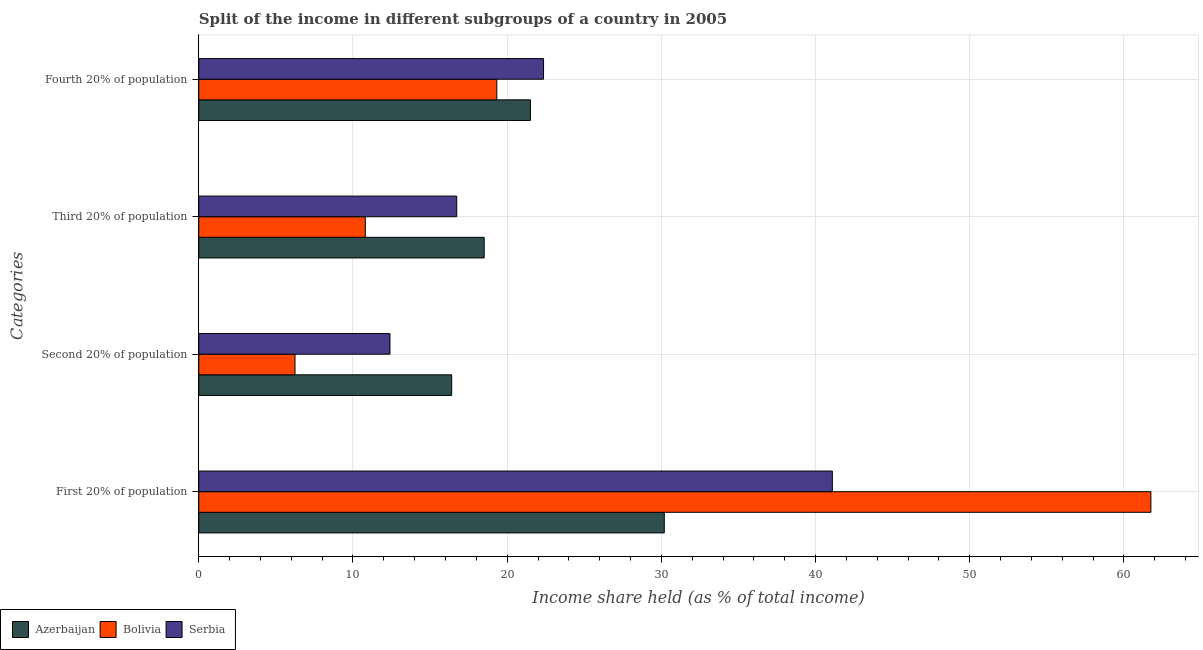How many groups of bars are there?
Provide a succinct answer. 4. Are the number of bars per tick equal to the number of legend labels?
Make the answer very short. Yes. What is the label of the 2nd group of bars from the top?
Make the answer very short. Third 20% of population. What is the share of the income held by fourth 20% of the population in Serbia?
Provide a succinct answer. 22.36. Across all countries, what is the maximum share of the income held by first 20% of the population?
Keep it short and to the point. 61.75. Across all countries, what is the minimum share of the income held by fourth 20% of the population?
Provide a short and direct response. 19.33. In which country was the share of the income held by fourth 20% of the population maximum?
Provide a succinct answer. Serbia. What is the total share of the income held by third 20% of the population in the graph?
Offer a very short reply. 46.04. What is the difference between the share of the income held by second 20% of the population in Serbia and that in Bolivia?
Your answer should be very brief. 6.16. What is the difference between the share of the income held by first 20% of the population in Bolivia and the share of the income held by fourth 20% of the population in Serbia?
Your answer should be very brief. 39.39. What is the average share of the income held by second 20% of the population per country?
Give a very brief answer. 11.68. What is the difference between the share of the income held by fourth 20% of the population and share of the income held by third 20% of the population in Bolivia?
Your response must be concise. 8.53. What is the ratio of the share of the income held by second 20% of the population in Azerbaijan to that in Serbia?
Make the answer very short. 1.32. What is the difference between the highest and the second highest share of the income held by fourth 20% of the population?
Your answer should be very brief. 0.85. What is the difference between the highest and the lowest share of the income held by fourth 20% of the population?
Offer a very short reply. 3.03. Is the sum of the share of the income held by first 20% of the population in Azerbaijan and Bolivia greater than the maximum share of the income held by second 20% of the population across all countries?
Make the answer very short. Yes. What does the 1st bar from the top in Third 20% of population represents?
Give a very brief answer. Serbia. What does the 1st bar from the bottom in Fourth 20% of population represents?
Make the answer very short. Azerbaijan. Is it the case that in every country, the sum of the share of the income held by first 20% of the population and share of the income held by second 20% of the population is greater than the share of the income held by third 20% of the population?
Provide a short and direct response. Yes. How many countries are there in the graph?
Your response must be concise. 3. What is the difference between two consecutive major ticks on the X-axis?
Your answer should be very brief. 10. Are the values on the major ticks of X-axis written in scientific E-notation?
Ensure brevity in your answer.  No. How many legend labels are there?
Offer a very short reply. 3. How are the legend labels stacked?
Your response must be concise. Horizontal. What is the title of the graph?
Provide a short and direct response. Split of the income in different subgroups of a country in 2005. What is the label or title of the X-axis?
Provide a short and direct response. Income share held (as % of total income). What is the label or title of the Y-axis?
Provide a short and direct response. Categories. What is the Income share held (as % of total income) of Azerbaijan in First 20% of population?
Make the answer very short. 30.19. What is the Income share held (as % of total income) in Bolivia in First 20% of population?
Keep it short and to the point. 61.75. What is the Income share held (as % of total income) of Serbia in First 20% of population?
Your answer should be very brief. 41.09. What is the Income share held (as % of total income) of Azerbaijan in Second 20% of population?
Offer a very short reply. 16.4. What is the Income share held (as % of total income) of Bolivia in Second 20% of population?
Ensure brevity in your answer.  6.24. What is the Income share held (as % of total income) of Azerbaijan in Third 20% of population?
Offer a very short reply. 18.51. What is the Income share held (as % of total income) in Bolivia in Third 20% of population?
Your answer should be compact. 10.8. What is the Income share held (as % of total income) of Serbia in Third 20% of population?
Your response must be concise. 16.73. What is the Income share held (as % of total income) in Azerbaijan in Fourth 20% of population?
Offer a very short reply. 21.51. What is the Income share held (as % of total income) in Bolivia in Fourth 20% of population?
Keep it short and to the point. 19.33. What is the Income share held (as % of total income) of Serbia in Fourth 20% of population?
Give a very brief answer. 22.36. Across all Categories, what is the maximum Income share held (as % of total income) of Azerbaijan?
Provide a succinct answer. 30.19. Across all Categories, what is the maximum Income share held (as % of total income) in Bolivia?
Ensure brevity in your answer.  61.75. Across all Categories, what is the maximum Income share held (as % of total income) in Serbia?
Keep it short and to the point. 41.09. Across all Categories, what is the minimum Income share held (as % of total income) of Azerbaijan?
Your response must be concise. 16.4. Across all Categories, what is the minimum Income share held (as % of total income) in Bolivia?
Offer a very short reply. 6.24. Across all Categories, what is the minimum Income share held (as % of total income) of Serbia?
Your answer should be compact. 12.4. What is the total Income share held (as % of total income) in Azerbaijan in the graph?
Ensure brevity in your answer.  86.61. What is the total Income share held (as % of total income) in Bolivia in the graph?
Ensure brevity in your answer.  98.12. What is the total Income share held (as % of total income) of Serbia in the graph?
Make the answer very short. 92.58. What is the difference between the Income share held (as % of total income) of Azerbaijan in First 20% of population and that in Second 20% of population?
Provide a succinct answer. 13.79. What is the difference between the Income share held (as % of total income) in Bolivia in First 20% of population and that in Second 20% of population?
Provide a succinct answer. 55.51. What is the difference between the Income share held (as % of total income) of Serbia in First 20% of population and that in Second 20% of population?
Offer a terse response. 28.69. What is the difference between the Income share held (as % of total income) of Azerbaijan in First 20% of population and that in Third 20% of population?
Provide a succinct answer. 11.68. What is the difference between the Income share held (as % of total income) of Bolivia in First 20% of population and that in Third 20% of population?
Provide a succinct answer. 50.95. What is the difference between the Income share held (as % of total income) of Serbia in First 20% of population and that in Third 20% of population?
Offer a very short reply. 24.36. What is the difference between the Income share held (as % of total income) in Azerbaijan in First 20% of population and that in Fourth 20% of population?
Your answer should be compact. 8.68. What is the difference between the Income share held (as % of total income) of Bolivia in First 20% of population and that in Fourth 20% of population?
Ensure brevity in your answer.  42.42. What is the difference between the Income share held (as % of total income) in Serbia in First 20% of population and that in Fourth 20% of population?
Your answer should be compact. 18.73. What is the difference between the Income share held (as % of total income) of Azerbaijan in Second 20% of population and that in Third 20% of population?
Offer a terse response. -2.11. What is the difference between the Income share held (as % of total income) of Bolivia in Second 20% of population and that in Third 20% of population?
Offer a very short reply. -4.56. What is the difference between the Income share held (as % of total income) of Serbia in Second 20% of population and that in Third 20% of population?
Provide a short and direct response. -4.33. What is the difference between the Income share held (as % of total income) of Azerbaijan in Second 20% of population and that in Fourth 20% of population?
Your answer should be compact. -5.11. What is the difference between the Income share held (as % of total income) in Bolivia in Second 20% of population and that in Fourth 20% of population?
Give a very brief answer. -13.09. What is the difference between the Income share held (as % of total income) in Serbia in Second 20% of population and that in Fourth 20% of population?
Your answer should be very brief. -9.96. What is the difference between the Income share held (as % of total income) of Bolivia in Third 20% of population and that in Fourth 20% of population?
Provide a succinct answer. -8.53. What is the difference between the Income share held (as % of total income) in Serbia in Third 20% of population and that in Fourth 20% of population?
Provide a short and direct response. -5.63. What is the difference between the Income share held (as % of total income) in Azerbaijan in First 20% of population and the Income share held (as % of total income) in Bolivia in Second 20% of population?
Keep it short and to the point. 23.95. What is the difference between the Income share held (as % of total income) in Azerbaijan in First 20% of population and the Income share held (as % of total income) in Serbia in Second 20% of population?
Provide a succinct answer. 17.79. What is the difference between the Income share held (as % of total income) in Bolivia in First 20% of population and the Income share held (as % of total income) in Serbia in Second 20% of population?
Offer a very short reply. 49.35. What is the difference between the Income share held (as % of total income) in Azerbaijan in First 20% of population and the Income share held (as % of total income) in Bolivia in Third 20% of population?
Make the answer very short. 19.39. What is the difference between the Income share held (as % of total income) in Azerbaijan in First 20% of population and the Income share held (as % of total income) in Serbia in Third 20% of population?
Ensure brevity in your answer.  13.46. What is the difference between the Income share held (as % of total income) in Bolivia in First 20% of population and the Income share held (as % of total income) in Serbia in Third 20% of population?
Your answer should be compact. 45.02. What is the difference between the Income share held (as % of total income) in Azerbaijan in First 20% of population and the Income share held (as % of total income) in Bolivia in Fourth 20% of population?
Make the answer very short. 10.86. What is the difference between the Income share held (as % of total income) in Azerbaijan in First 20% of population and the Income share held (as % of total income) in Serbia in Fourth 20% of population?
Give a very brief answer. 7.83. What is the difference between the Income share held (as % of total income) in Bolivia in First 20% of population and the Income share held (as % of total income) in Serbia in Fourth 20% of population?
Your answer should be very brief. 39.39. What is the difference between the Income share held (as % of total income) of Azerbaijan in Second 20% of population and the Income share held (as % of total income) of Serbia in Third 20% of population?
Your response must be concise. -0.33. What is the difference between the Income share held (as % of total income) in Bolivia in Second 20% of population and the Income share held (as % of total income) in Serbia in Third 20% of population?
Your answer should be compact. -10.49. What is the difference between the Income share held (as % of total income) in Azerbaijan in Second 20% of population and the Income share held (as % of total income) in Bolivia in Fourth 20% of population?
Give a very brief answer. -2.93. What is the difference between the Income share held (as % of total income) of Azerbaijan in Second 20% of population and the Income share held (as % of total income) of Serbia in Fourth 20% of population?
Make the answer very short. -5.96. What is the difference between the Income share held (as % of total income) in Bolivia in Second 20% of population and the Income share held (as % of total income) in Serbia in Fourth 20% of population?
Make the answer very short. -16.12. What is the difference between the Income share held (as % of total income) in Azerbaijan in Third 20% of population and the Income share held (as % of total income) in Bolivia in Fourth 20% of population?
Offer a terse response. -0.82. What is the difference between the Income share held (as % of total income) in Azerbaijan in Third 20% of population and the Income share held (as % of total income) in Serbia in Fourth 20% of population?
Make the answer very short. -3.85. What is the difference between the Income share held (as % of total income) of Bolivia in Third 20% of population and the Income share held (as % of total income) of Serbia in Fourth 20% of population?
Give a very brief answer. -11.56. What is the average Income share held (as % of total income) of Azerbaijan per Categories?
Your answer should be compact. 21.65. What is the average Income share held (as % of total income) in Bolivia per Categories?
Give a very brief answer. 24.53. What is the average Income share held (as % of total income) of Serbia per Categories?
Your answer should be very brief. 23.14. What is the difference between the Income share held (as % of total income) in Azerbaijan and Income share held (as % of total income) in Bolivia in First 20% of population?
Give a very brief answer. -31.56. What is the difference between the Income share held (as % of total income) of Bolivia and Income share held (as % of total income) of Serbia in First 20% of population?
Make the answer very short. 20.66. What is the difference between the Income share held (as % of total income) in Azerbaijan and Income share held (as % of total income) in Bolivia in Second 20% of population?
Provide a succinct answer. 10.16. What is the difference between the Income share held (as % of total income) in Bolivia and Income share held (as % of total income) in Serbia in Second 20% of population?
Ensure brevity in your answer.  -6.16. What is the difference between the Income share held (as % of total income) in Azerbaijan and Income share held (as % of total income) in Bolivia in Third 20% of population?
Your answer should be very brief. 7.71. What is the difference between the Income share held (as % of total income) in Azerbaijan and Income share held (as % of total income) in Serbia in Third 20% of population?
Provide a succinct answer. 1.78. What is the difference between the Income share held (as % of total income) in Bolivia and Income share held (as % of total income) in Serbia in Third 20% of population?
Make the answer very short. -5.93. What is the difference between the Income share held (as % of total income) of Azerbaijan and Income share held (as % of total income) of Bolivia in Fourth 20% of population?
Give a very brief answer. 2.18. What is the difference between the Income share held (as % of total income) in Azerbaijan and Income share held (as % of total income) in Serbia in Fourth 20% of population?
Ensure brevity in your answer.  -0.85. What is the difference between the Income share held (as % of total income) in Bolivia and Income share held (as % of total income) in Serbia in Fourth 20% of population?
Your answer should be compact. -3.03. What is the ratio of the Income share held (as % of total income) of Azerbaijan in First 20% of population to that in Second 20% of population?
Provide a succinct answer. 1.84. What is the ratio of the Income share held (as % of total income) of Bolivia in First 20% of population to that in Second 20% of population?
Your answer should be very brief. 9.9. What is the ratio of the Income share held (as % of total income) in Serbia in First 20% of population to that in Second 20% of population?
Your response must be concise. 3.31. What is the ratio of the Income share held (as % of total income) of Azerbaijan in First 20% of population to that in Third 20% of population?
Provide a short and direct response. 1.63. What is the ratio of the Income share held (as % of total income) in Bolivia in First 20% of population to that in Third 20% of population?
Ensure brevity in your answer.  5.72. What is the ratio of the Income share held (as % of total income) of Serbia in First 20% of population to that in Third 20% of population?
Your response must be concise. 2.46. What is the ratio of the Income share held (as % of total income) in Azerbaijan in First 20% of population to that in Fourth 20% of population?
Give a very brief answer. 1.4. What is the ratio of the Income share held (as % of total income) in Bolivia in First 20% of population to that in Fourth 20% of population?
Your answer should be compact. 3.19. What is the ratio of the Income share held (as % of total income) in Serbia in First 20% of population to that in Fourth 20% of population?
Keep it short and to the point. 1.84. What is the ratio of the Income share held (as % of total income) in Azerbaijan in Second 20% of population to that in Third 20% of population?
Offer a very short reply. 0.89. What is the ratio of the Income share held (as % of total income) of Bolivia in Second 20% of population to that in Third 20% of population?
Your answer should be compact. 0.58. What is the ratio of the Income share held (as % of total income) of Serbia in Second 20% of population to that in Third 20% of population?
Your answer should be very brief. 0.74. What is the ratio of the Income share held (as % of total income) of Azerbaijan in Second 20% of population to that in Fourth 20% of population?
Keep it short and to the point. 0.76. What is the ratio of the Income share held (as % of total income) of Bolivia in Second 20% of population to that in Fourth 20% of population?
Make the answer very short. 0.32. What is the ratio of the Income share held (as % of total income) in Serbia in Second 20% of population to that in Fourth 20% of population?
Make the answer very short. 0.55. What is the ratio of the Income share held (as % of total income) in Azerbaijan in Third 20% of population to that in Fourth 20% of population?
Your answer should be very brief. 0.86. What is the ratio of the Income share held (as % of total income) of Bolivia in Third 20% of population to that in Fourth 20% of population?
Your answer should be compact. 0.56. What is the ratio of the Income share held (as % of total income) of Serbia in Third 20% of population to that in Fourth 20% of population?
Ensure brevity in your answer.  0.75. What is the difference between the highest and the second highest Income share held (as % of total income) in Azerbaijan?
Offer a very short reply. 8.68. What is the difference between the highest and the second highest Income share held (as % of total income) of Bolivia?
Your response must be concise. 42.42. What is the difference between the highest and the second highest Income share held (as % of total income) of Serbia?
Your answer should be compact. 18.73. What is the difference between the highest and the lowest Income share held (as % of total income) in Azerbaijan?
Give a very brief answer. 13.79. What is the difference between the highest and the lowest Income share held (as % of total income) of Bolivia?
Your response must be concise. 55.51. What is the difference between the highest and the lowest Income share held (as % of total income) of Serbia?
Ensure brevity in your answer.  28.69. 